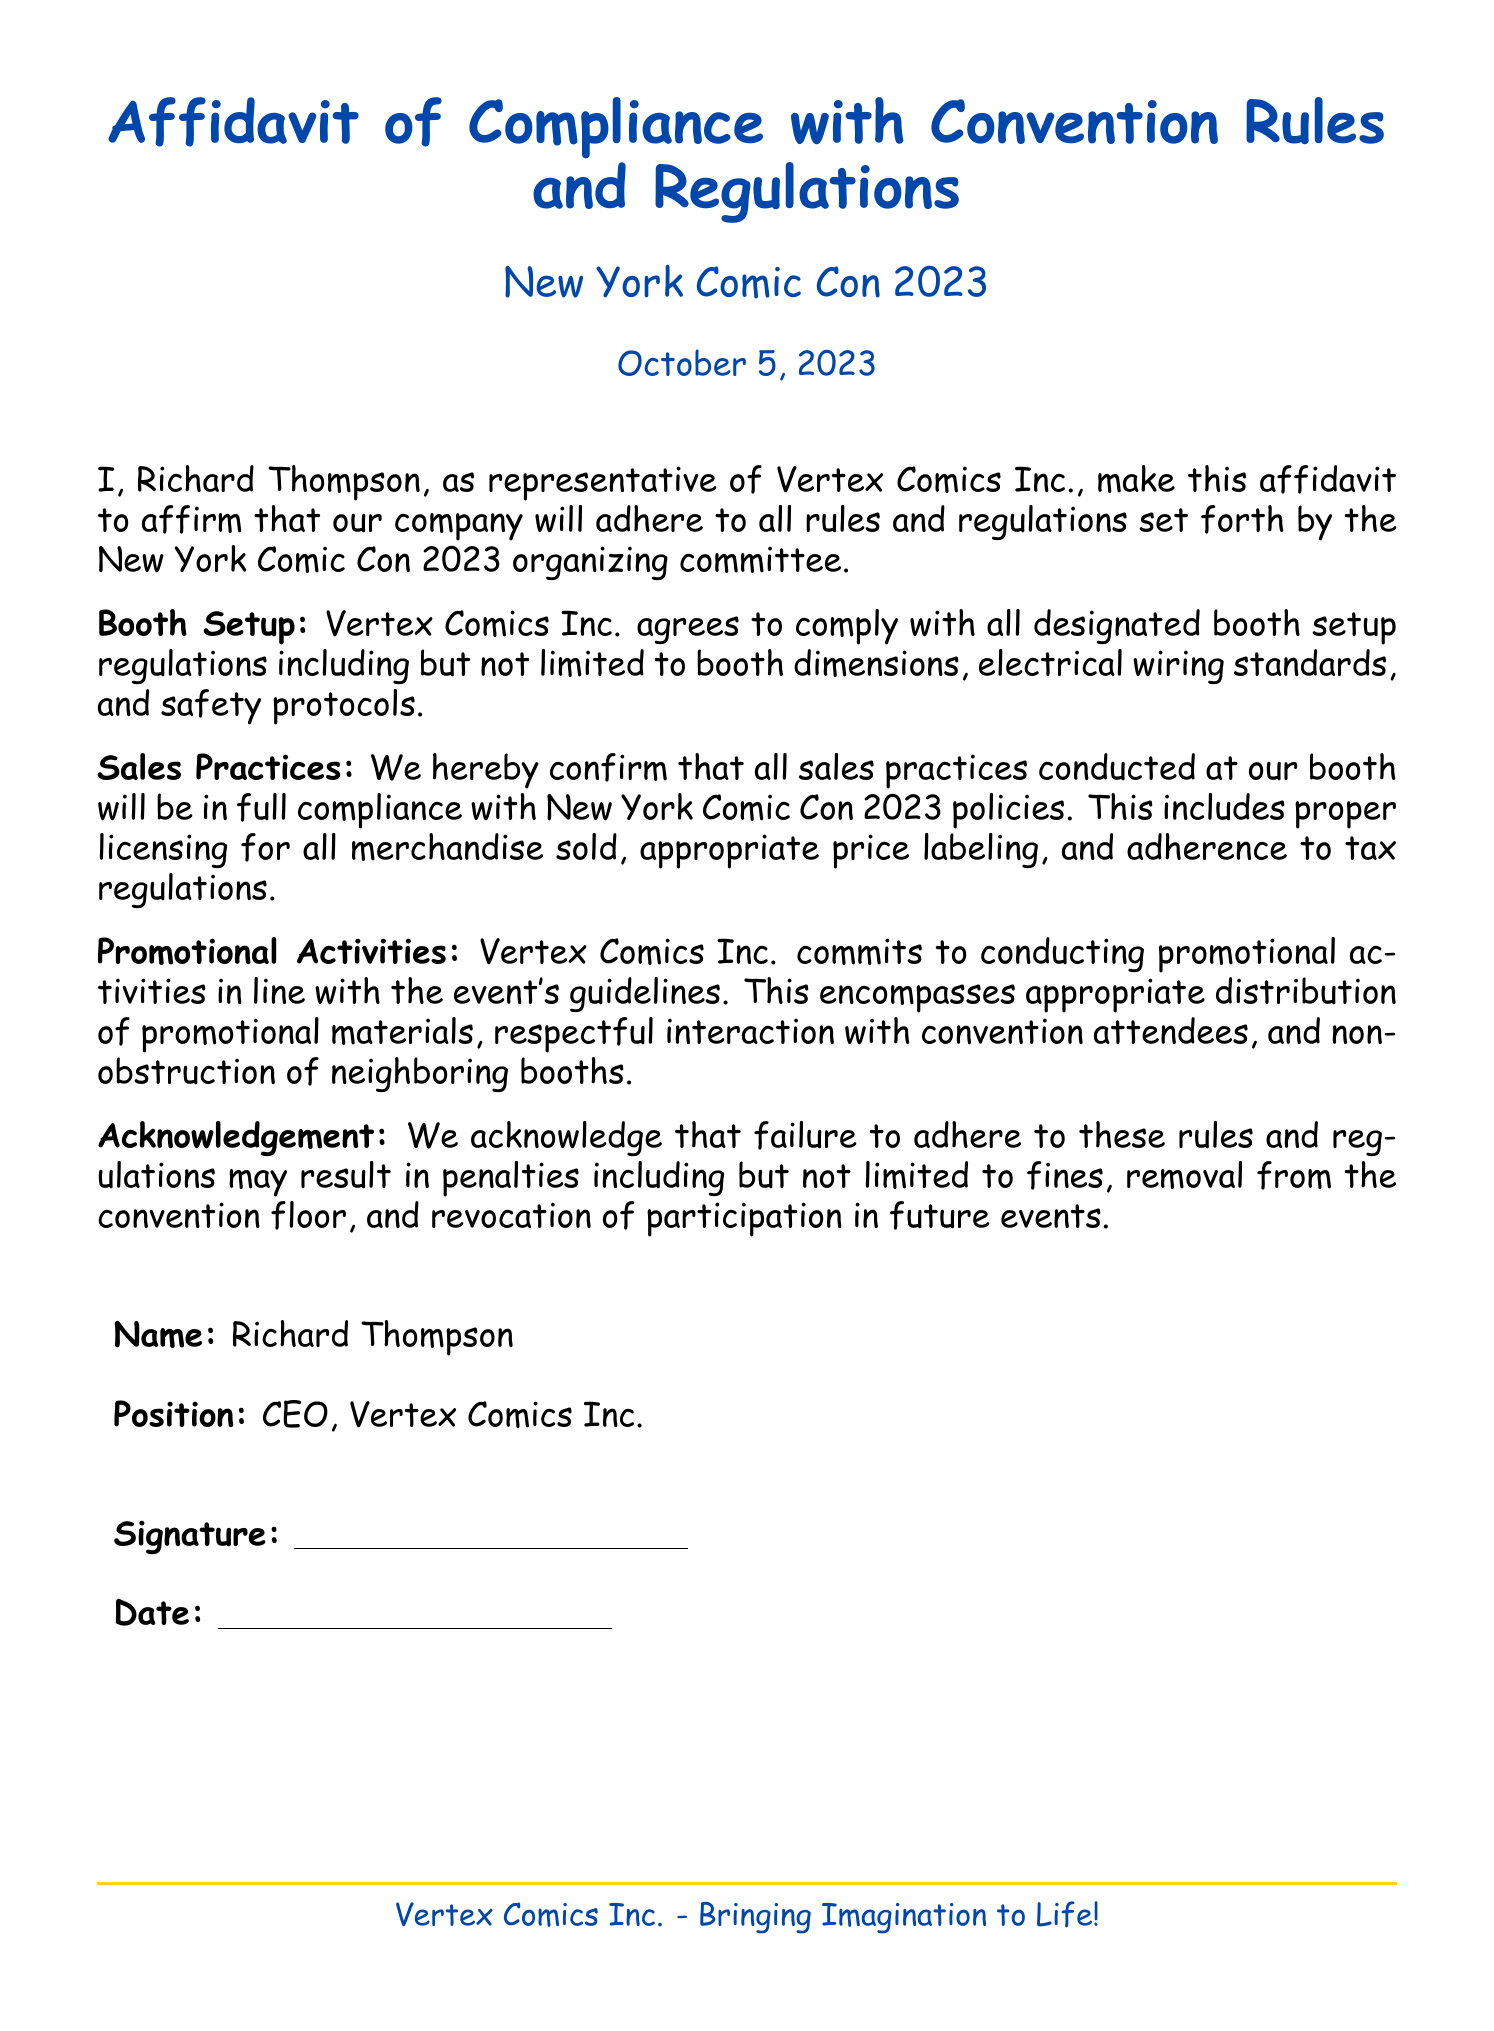What is the name of the CEO? The CEO of Vertex Comics Inc. is Richard Thompson, as stated in the document.
Answer: Richard Thompson What is the date of the affidavit? The date mentioned in the affidavit is October 5, 2023.
Answer: October 5, 2023 Which company is represented in the affidavit? The affidavit is made on behalf of Vertex Comics Inc., indicated at the beginning of the document.
Answer: Vertex Comics Inc What color is the text in the header? The text in the header section is colored comic blue, as defined in the document.
Answer: comic blue What might happen for failure to comply with the rules? The document states that failure to adhere may result in penalties including fines, removal, and revocation.
Answer: Penalties including fines What section discusses booth setup? The section dedicated to booth setup is labeled "Booth Setup".
Answer: Booth Setup How does Vertex Comics Inc. describe its business? The document concludes with a tagline “Bringing Imagination to Life!” describing Vertex Comics Inc.
Answer: Bringing Imagination to Life! What is required for sales practices at the booth? Sales practices must comply with licensing, price labeling, and tax regulations according to the affidavit.
Answer: Licensing for all merchandise sold What is mentioned about promotional activities? The affidavit states that promotional activities must align with event guidelines.
Answer: Align with event guidelines 